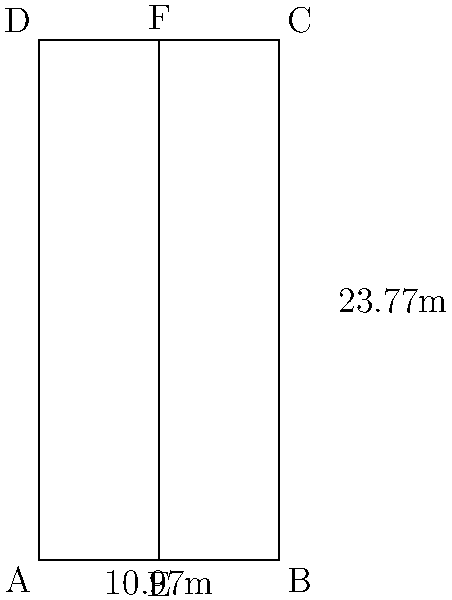As a professional tennis player, you're familiar with the dimensions of a tennis court. The diagram shows a simplified representation of a singles tennis court. If you were to estimate the area of the court using a rectangle, what would be the approximate area in square meters? Round your answer to the nearest whole number. To estimate the area of the tennis court using a rectangle, we need to follow these steps:

1. Identify the length and width of the court:
   - Length (from A to B or D to C) = 23.77 meters
   - Width (from A to D or B to C) = 10.97 meters

2. Use the formula for the area of a rectangle:
   $$ \text{Area} = \text{length} \times \text{width} $$

3. Plug in the values:
   $$ \text{Area} = 23.77 \text{ m} \times 10.97 \text{ m} $$

4. Calculate:
   $$ \text{Area} = 260.7569 \text{ m}^2 $$

5. Round to the nearest whole number:
   $$ \text{Area} \approx 261 \text{ m}^2 $$

Therefore, the estimated area of the tennis court, rounded to the nearest whole number, is 261 square meters.
Answer: 261 m² 